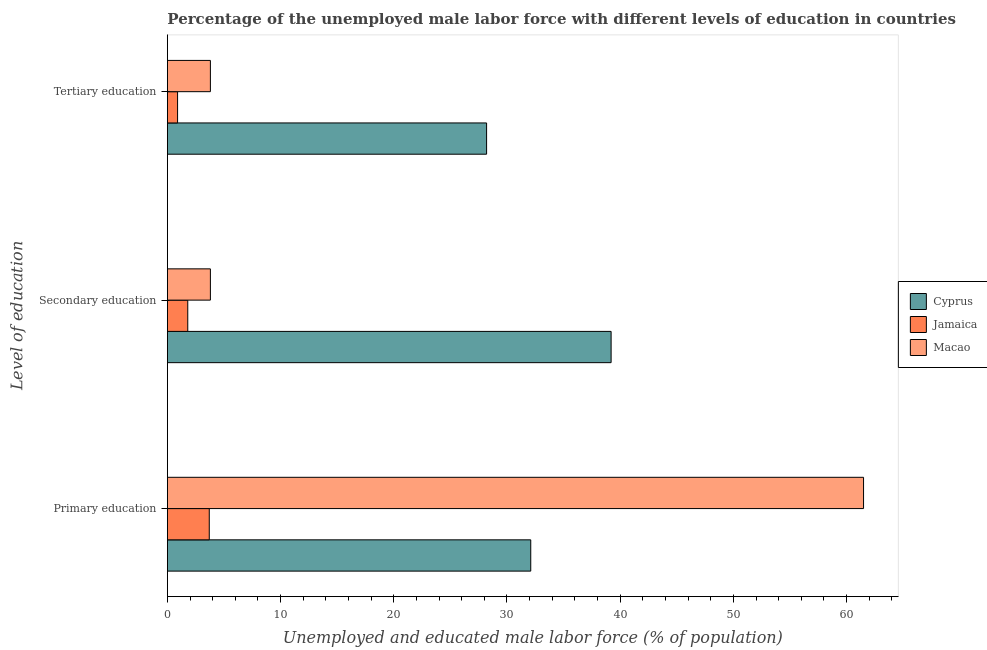Are the number of bars per tick equal to the number of legend labels?
Ensure brevity in your answer.  Yes. How many bars are there on the 3rd tick from the top?
Your answer should be compact. 3. How many bars are there on the 3rd tick from the bottom?
Your answer should be very brief. 3. What is the label of the 3rd group of bars from the top?
Keep it short and to the point. Primary education. What is the percentage of male labor force who received primary education in Jamaica?
Provide a succinct answer. 3.7. Across all countries, what is the maximum percentage of male labor force who received primary education?
Keep it short and to the point. 61.5. Across all countries, what is the minimum percentage of male labor force who received tertiary education?
Keep it short and to the point. 0.9. In which country was the percentage of male labor force who received tertiary education maximum?
Give a very brief answer. Cyprus. In which country was the percentage of male labor force who received tertiary education minimum?
Ensure brevity in your answer.  Jamaica. What is the total percentage of male labor force who received primary education in the graph?
Provide a succinct answer. 97.3. What is the difference between the percentage of male labor force who received primary education in Cyprus and that in Macao?
Ensure brevity in your answer.  -29.4. What is the difference between the percentage of male labor force who received tertiary education in Macao and the percentage of male labor force who received secondary education in Cyprus?
Provide a short and direct response. -35.4. What is the average percentage of male labor force who received tertiary education per country?
Offer a terse response. 10.97. What is the difference between the percentage of male labor force who received secondary education and percentage of male labor force who received tertiary education in Jamaica?
Offer a terse response. 0.9. In how many countries, is the percentage of male labor force who received primary education greater than 10 %?
Give a very brief answer. 2. What is the ratio of the percentage of male labor force who received secondary education in Jamaica to that in Cyprus?
Provide a short and direct response. 0.05. Is the percentage of male labor force who received secondary education in Macao less than that in Cyprus?
Ensure brevity in your answer.  Yes. Is the difference between the percentage of male labor force who received primary education in Macao and Jamaica greater than the difference between the percentage of male labor force who received tertiary education in Macao and Jamaica?
Your answer should be compact. Yes. What is the difference between the highest and the second highest percentage of male labor force who received primary education?
Offer a very short reply. 29.4. What is the difference between the highest and the lowest percentage of male labor force who received tertiary education?
Provide a short and direct response. 27.3. Is the sum of the percentage of male labor force who received primary education in Cyprus and Jamaica greater than the maximum percentage of male labor force who received tertiary education across all countries?
Your answer should be very brief. Yes. What does the 1st bar from the top in Primary education represents?
Offer a terse response. Macao. What does the 1st bar from the bottom in Tertiary education represents?
Keep it short and to the point. Cyprus. Is it the case that in every country, the sum of the percentage of male labor force who received primary education and percentage of male labor force who received secondary education is greater than the percentage of male labor force who received tertiary education?
Offer a very short reply. Yes. How many bars are there?
Make the answer very short. 9. Are all the bars in the graph horizontal?
Your response must be concise. Yes. Does the graph contain any zero values?
Your response must be concise. No. Does the graph contain grids?
Provide a succinct answer. No. How many legend labels are there?
Offer a terse response. 3. What is the title of the graph?
Offer a very short reply. Percentage of the unemployed male labor force with different levels of education in countries. Does "Iran" appear as one of the legend labels in the graph?
Offer a very short reply. No. What is the label or title of the X-axis?
Offer a very short reply. Unemployed and educated male labor force (% of population). What is the label or title of the Y-axis?
Offer a terse response. Level of education. What is the Unemployed and educated male labor force (% of population) of Cyprus in Primary education?
Ensure brevity in your answer.  32.1. What is the Unemployed and educated male labor force (% of population) in Jamaica in Primary education?
Make the answer very short. 3.7. What is the Unemployed and educated male labor force (% of population) of Macao in Primary education?
Offer a very short reply. 61.5. What is the Unemployed and educated male labor force (% of population) in Cyprus in Secondary education?
Give a very brief answer. 39.2. What is the Unemployed and educated male labor force (% of population) in Jamaica in Secondary education?
Give a very brief answer. 1.8. What is the Unemployed and educated male labor force (% of population) of Macao in Secondary education?
Offer a terse response. 3.8. What is the Unemployed and educated male labor force (% of population) of Cyprus in Tertiary education?
Make the answer very short. 28.2. What is the Unemployed and educated male labor force (% of population) in Jamaica in Tertiary education?
Offer a very short reply. 0.9. What is the Unemployed and educated male labor force (% of population) in Macao in Tertiary education?
Ensure brevity in your answer.  3.8. Across all Level of education, what is the maximum Unemployed and educated male labor force (% of population) in Cyprus?
Your response must be concise. 39.2. Across all Level of education, what is the maximum Unemployed and educated male labor force (% of population) in Jamaica?
Provide a short and direct response. 3.7. Across all Level of education, what is the maximum Unemployed and educated male labor force (% of population) in Macao?
Your answer should be very brief. 61.5. Across all Level of education, what is the minimum Unemployed and educated male labor force (% of population) in Cyprus?
Offer a very short reply. 28.2. Across all Level of education, what is the minimum Unemployed and educated male labor force (% of population) in Jamaica?
Keep it short and to the point. 0.9. Across all Level of education, what is the minimum Unemployed and educated male labor force (% of population) of Macao?
Your answer should be compact. 3.8. What is the total Unemployed and educated male labor force (% of population) in Cyprus in the graph?
Provide a succinct answer. 99.5. What is the total Unemployed and educated male labor force (% of population) of Jamaica in the graph?
Make the answer very short. 6.4. What is the total Unemployed and educated male labor force (% of population) in Macao in the graph?
Your response must be concise. 69.1. What is the difference between the Unemployed and educated male labor force (% of population) in Jamaica in Primary education and that in Secondary education?
Make the answer very short. 1.9. What is the difference between the Unemployed and educated male labor force (% of population) of Macao in Primary education and that in Secondary education?
Keep it short and to the point. 57.7. What is the difference between the Unemployed and educated male labor force (% of population) of Cyprus in Primary education and that in Tertiary education?
Ensure brevity in your answer.  3.9. What is the difference between the Unemployed and educated male labor force (% of population) of Macao in Primary education and that in Tertiary education?
Your answer should be very brief. 57.7. What is the difference between the Unemployed and educated male labor force (% of population) in Macao in Secondary education and that in Tertiary education?
Ensure brevity in your answer.  0. What is the difference between the Unemployed and educated male labor force (% of population) in Cyprus in Primary education and the Unemployed and educated male labor force (% of population) in Jamaica in Secondary education?
Provide a succinct answer. 30.3. What is the difference between the Unemployed and educated male labor force (% of population) of Cyprus in Primary education and the Unemployed and educated male labor force (% of population) of Macao in Secondary education?
Offer a terse response. 28.3. What is the difference between the Unemployed and educated male labor force (% of population) in Cyprus in Primary education and the Unemployed and educated male labor force (% of population) in Jamaica in Tertiary education?
Provide a short and direct response. 31.2. What is the difference between the Unemployed and educated male labor force (% of population) of Cyprus in Primary education and the Unemployed and educated male labor force (% of population) of Macao in Tertiary education?
Offer a very short reply. 28.3. What is the difference between the Unemployed and educated male labor force (% of population) of Jamaica in Primary education and the Unemployed and educated male labor force (% of population) of Macao in Tertiary education?
Provide a succinct answer. -0.1. What is the difference between the Unemployed and educated male labor force (% of population) in Cyprus in Secondary education and the Unemployed and educated male labor force (% of population) in Jamaica in Tertiary education?
Your answer should be compact. 38.3. What is the difference between the Unemployed and educated male labor force (% of population) in Cyprus in Secondary education and the Unemployed and educated male labor force (% of population) in Macao in Tertiary education?
Your answer should be very brief. 35.4. What is the average Unemployed and educated male labor force (% of population) in Cyprus per Level of education?
Keep it short and to the point. 33.17. What is the average Unemployed and educated male labor force (% of population) of Jamaica per Level of education?
Your answer should be compact. 2.13. What is the average Unemployed and educated male labor force (% of population) in Macao per Level of education?
Provide a succinct answer. 23.03. What is the difference between the Unemployed and educated male labor force (% of population) of Cyprus and Unemployed and educated male labor force (% of population) of Jamaica in Primary education?
Make the answer very short. 28.4. What is the difference between the Unemployed and educated male labor force (% of population) in Cyprus and Unemployed and educated male labor force (% of population) in Macao in Primary education?
Give a very brief answer. -29.4. What is the difference between the Unemployed and educated male labor force (% of population) in Jamaica and Unemployed and educated male labor force (% of population) in Macao in Primary education?
Your answer should be very brief. -57.8. What is the difference between the Unemployed and educated male labor force (% of population) of Cyprus and Unemployed and educated male labor force (% of population) of Jamaica in Secondary education?
Keep it short and to the point. 37.4. What is the difference between the Unemployed and educated male labor force (% of population) in Cyprus and Unemployed and educated male labor force (% of population) in Macao in Secondary education?
Your response must be concise. 35.4. What is the difference between the Unemployed and educated male labor force (% of population) in Jamaica and Unemployed and educated male labor force (% of population) in Macao in Secondary education?
Make the answer very short. -2. What is the difference between the Unemployed and educated male labor force (% of population) of Cyprus and Unemployed and educated male labor force (% of population) of Jamaica in Tertiary education?
Provide a succinct answer. 27.3. What is the difference between the Unemployed and educated male labor force (% of population) in Cyprus and Unemployed and educated male labor force (% of population) in Macao in Tertiary education?
Your response must be concise. 24.4. What is the ratio of the Unemployed and educated male labor force (% of population) in Cyprus in Primary education to that in Secondary education?
Your answer should be very brief. 0.82. What is the ratio of the Unemployed and educated male labor force (% of population) in Jamaica in Primary education to that in Secondary education?
Your response must be concise. 2.06. What is the ratio of the Unemployed and educated male labor force (% of population) in Macao in Primary education to that in Secondary education?
Offer a very short reply. 16.18. What is the ratio of the Unemployed and educated male labor force (% of population) of Cyprus in Primary education to that in Tertiary education?
Your answer should be very brief. 1.14. What is the ratio of the Unemployed and educated male labor force (% of population) of Jamaica in Primary education to that in Tertiary education?
Provide a short and direct response. 4.11. What is the ratio of the Unemployed and educated male labor force (% of population) in Macao in Primary education to that in Tertiary education?
Your answer should be compact. 16.18. What is the ratio of the Unemployed and educated male labor force (% of population) of Cyprus in Secondary education to that in Tertiary education?
Give a very brief answer. 1.39. What is the ratio of the Unemployed and educated male labor force (% of population) of Jamaica in Secondary education to that in Tertiary education?
Ensure brevity in your answer.  2. What is the difference between the highest and the second highest Unemployed and educated male labor force (% of population) in Cyprus?
Your answer should be compact. 7.1. What is the difference between the highest and the second highest Unemployed and educated male labor force (% of population) in Jamaica?
Make the answer very short. 1.9. What is the difference between the highest and the second highest Unemployed and educated male labor force (% of population) of Macao?
Offer a very short reply. 57.7. What is the difference between the highest and the lowest Unemployed and educated male labor force (% of population) in Cyprus?
Keep it short and to the point. 11. What is the difference between the highest and the lowest Unemployed and educated male labor force (% of population) of Macao?
Ensure brevity in your answer.  57.7. 